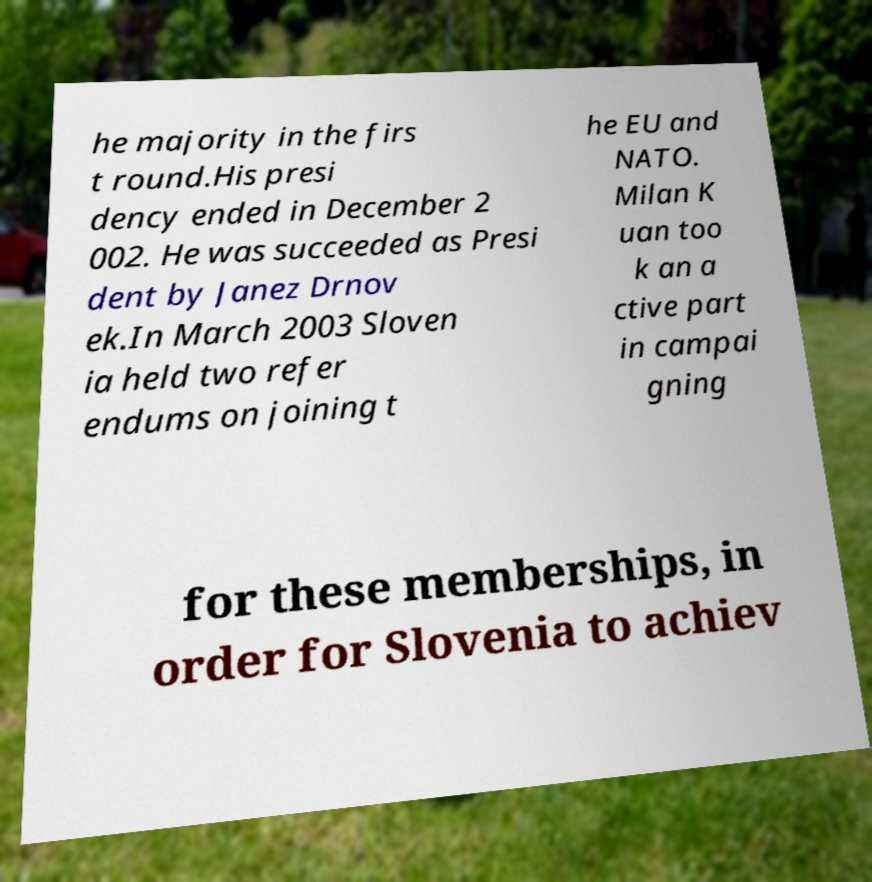Can you accurately transcribe the text from the provided image for me? he majority in the firs t round.His presi dency ended in December 2 002. He was succeeded as Presi dent by Janez Drnov ek.In March 2003 Sloven ia held two refer endums on joining t he EU and NATO. Milan K uan too k an a ctive part in campai gning for these memberships, in order for Slovenia to achiev 